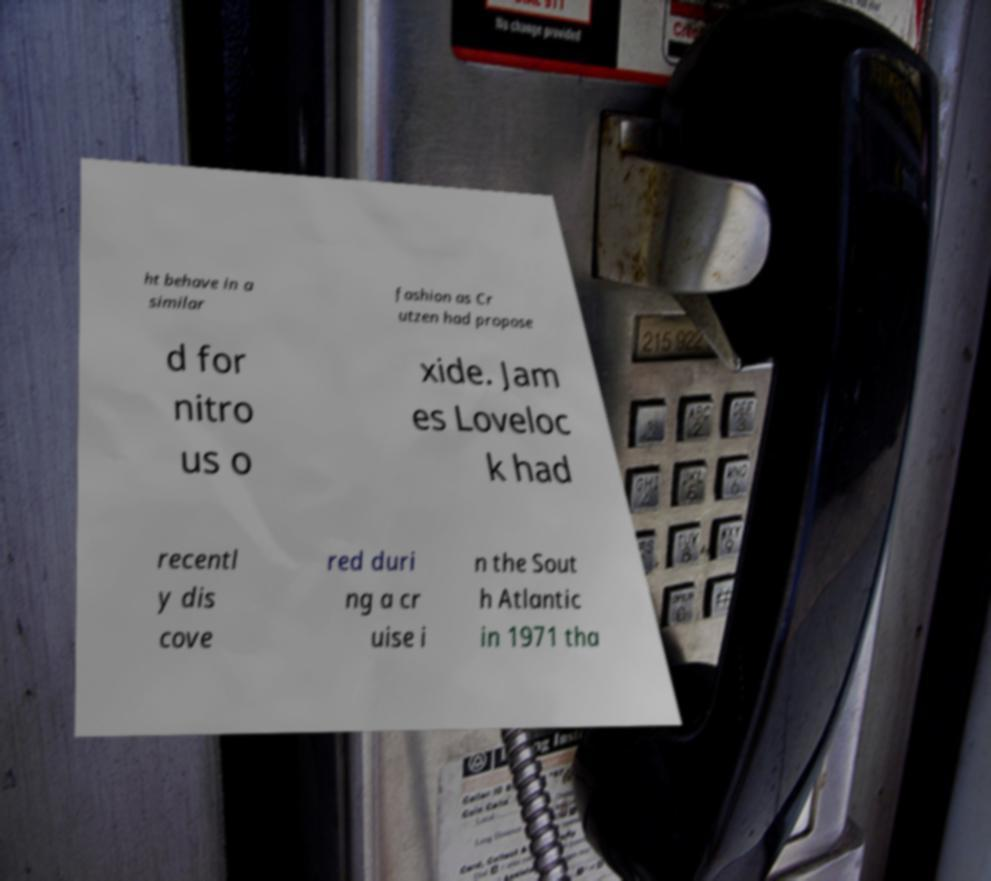What messages or text are displayed in this image? I need them in a readable, typed format. ht behave in a similar fashion as Cr utzen had propose d for nitro us o xide. Jam es Loveloc k had recentl y dis cove red duri ng a cr uise i n the Sout h Atlantic in 1971 tha 